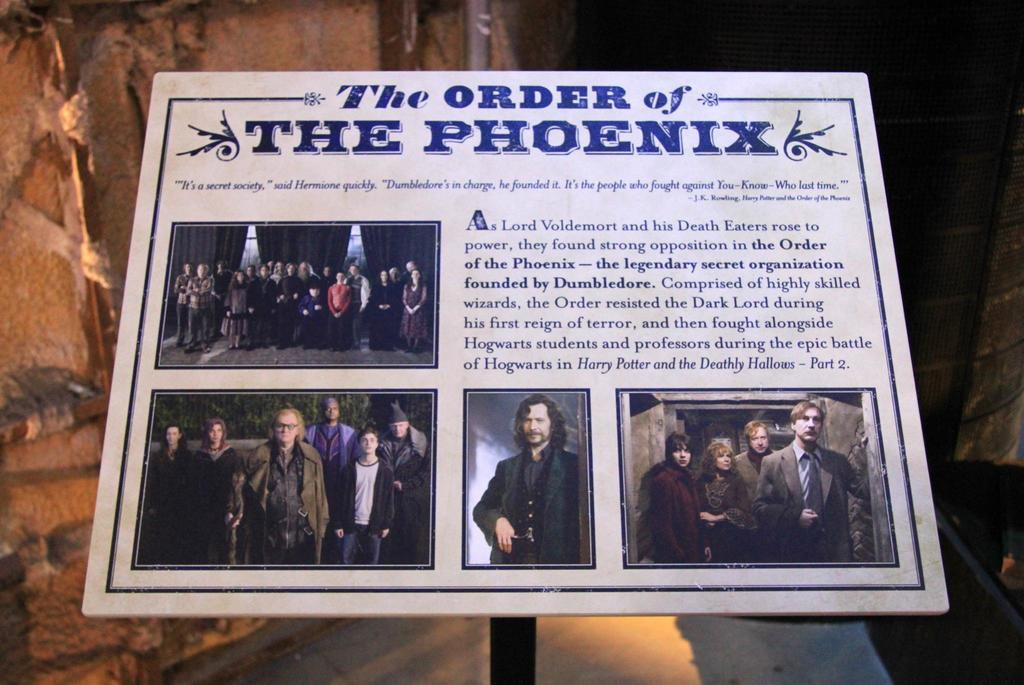Provide a one-sentence caption for the provided image. the order of the phoenix poster advertise a play. 